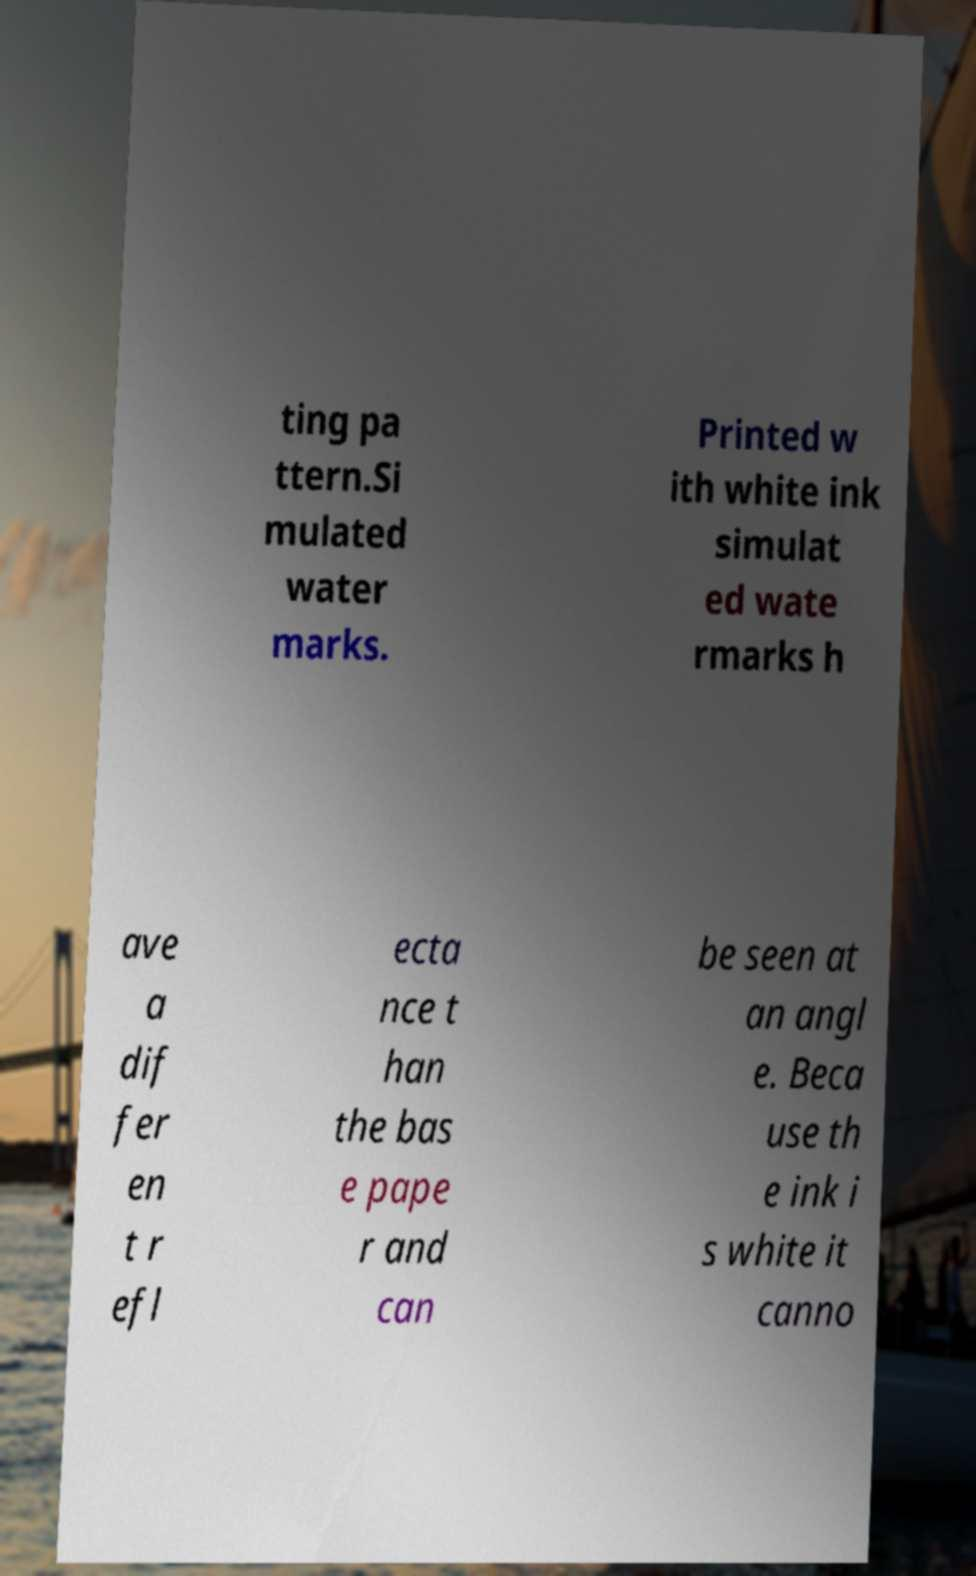Could you assist in decoding the text presented in this image and type it out clearly? ting pa ttern.Si mulated water marks. Printed w ith white ink simulat ed wate rmarks h ave a dif fer en t r efl ecta nce t han the bas e pape r and can be seen at an angl e. Beca use th e ink i s white it canno 